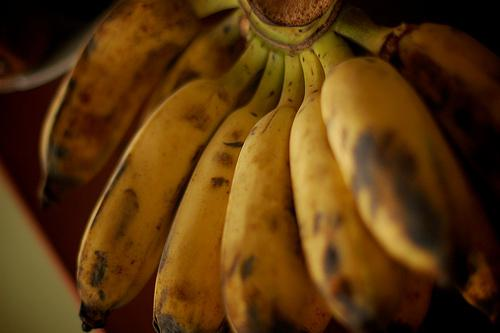Question: what fruit is shown?
Choices:
A. Apples.
B. Bananas.
C. Oranges.
D. Pears.
Answer with the letter. Answer: B Question: what color are the bananas?
Choices:
A. Brown.
B. Green.
C. Black.
D. Yellow.
Answer with the letter. Answer: D Question: what is the dark spots?
Choices:
A. Holes.
B. Leaves.
C. Bruising.
D. Dirt.
Answer with the letter. Answer: C Question: how many bunches of bananas are shown?
Choices:
A. 4.
B. 2.
C. 6.
D. 5.
Answer with the letter. Answer: B Question: how many bananas are in the picture?
Choices:
A. 4.
B. 6.
C. 5.
D. 8.
Answer with the letter. Answer: B Question: how many animals are shown?
Choices:
A. 0.
B. 1.
C. 3.
D. 2.
Answer with the letter. Answer: A 